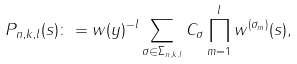<formula> <loc_0><loc_0><loc_500><loc_500>P _ { n , k , l } ( s ) \colon = w ( y ) ^ { - l } \sum _ { \sigma \in \Sigma _ { n , k , l } } C _ { \sigma } \prod _ { m = 1 } ^ { l } w ^ { ( \sigma _ { m } ) } ( s ) ,</formula> 